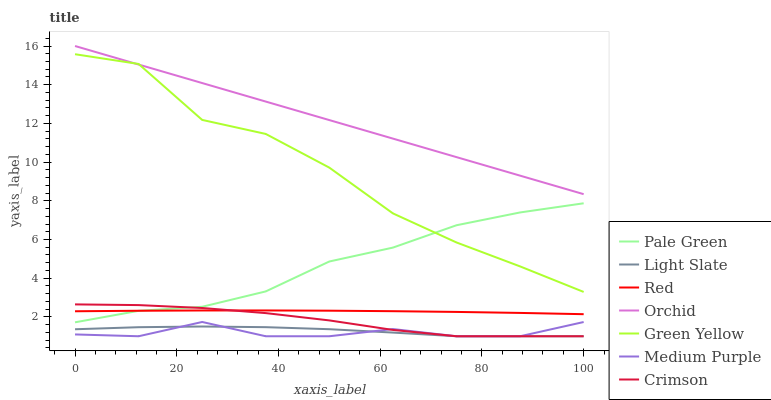Does Medium Purple have the minimum area under the curve?
Answer yes or no. Yes. Does Orchid have the maximum area under the curve?
Answer yes or no. Yes. Does Pale Green have the minimum area under the curve?
Answer yes or no. No. Does Pale Green have the maximum area under the curve?
Answer yes or no. No. Is Orchid the smoothest?
Answer yes or no. Yes. Is Green Yellow the roughest?
Answer yes or no. Yes. Is Medium Purple the smoothest?
Answer yes or no. No. Is Medium Purple the roughest?
Answer yes or no. No. Does Light Slate have the lowest value?
Answer yes or no. Yes. Does Pale Green have the lowest value?
Answer yes or no. No. Does Orchid have the highest value?
Answer yes or no. Yes. Does Medium Purple have the highest value?
Answer yes or no. No. Is Pale Green less than Orchid?
Answer yes or no. Yes. Is Green Yellow greater than Crimson?
Answer yes or no. Yes. Does Pale Green intersect Green Yellow?
Answer yes or no. Yes. Is Pale Green less than Green Yellow?
Answer yes or no. No. Is Pale Green greater than Green Yellow?
Answer yes or no. No. Does Pale Green intersect Orchid?
Answer yes or no. No. 